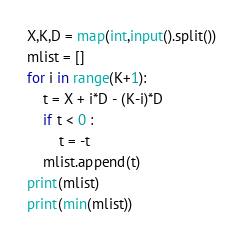Convert code to text. <code><loc_0><loc_0><loc_500><loc_500><_Python_>X,K,D = map(int,input().split()) 
mlist = []
for i in range(K+1):
    t = X + i*D - (K-i)*D
    if t < 0 :
        t = -t
    mlist.append(t)
print(mlist)
print(min(mlist))</code> 